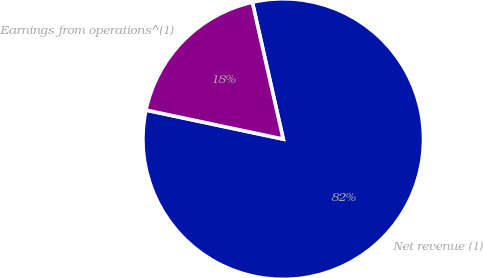Convert chart to OTSL. <chart><loc_0><loc_0><loc_500><loc_500><pie_chart><fcel>Net revenue (1)<fcel>Earnings from operations^(1)<nl><fcel>81.85%<fcel>18.15%<nl></chart> 